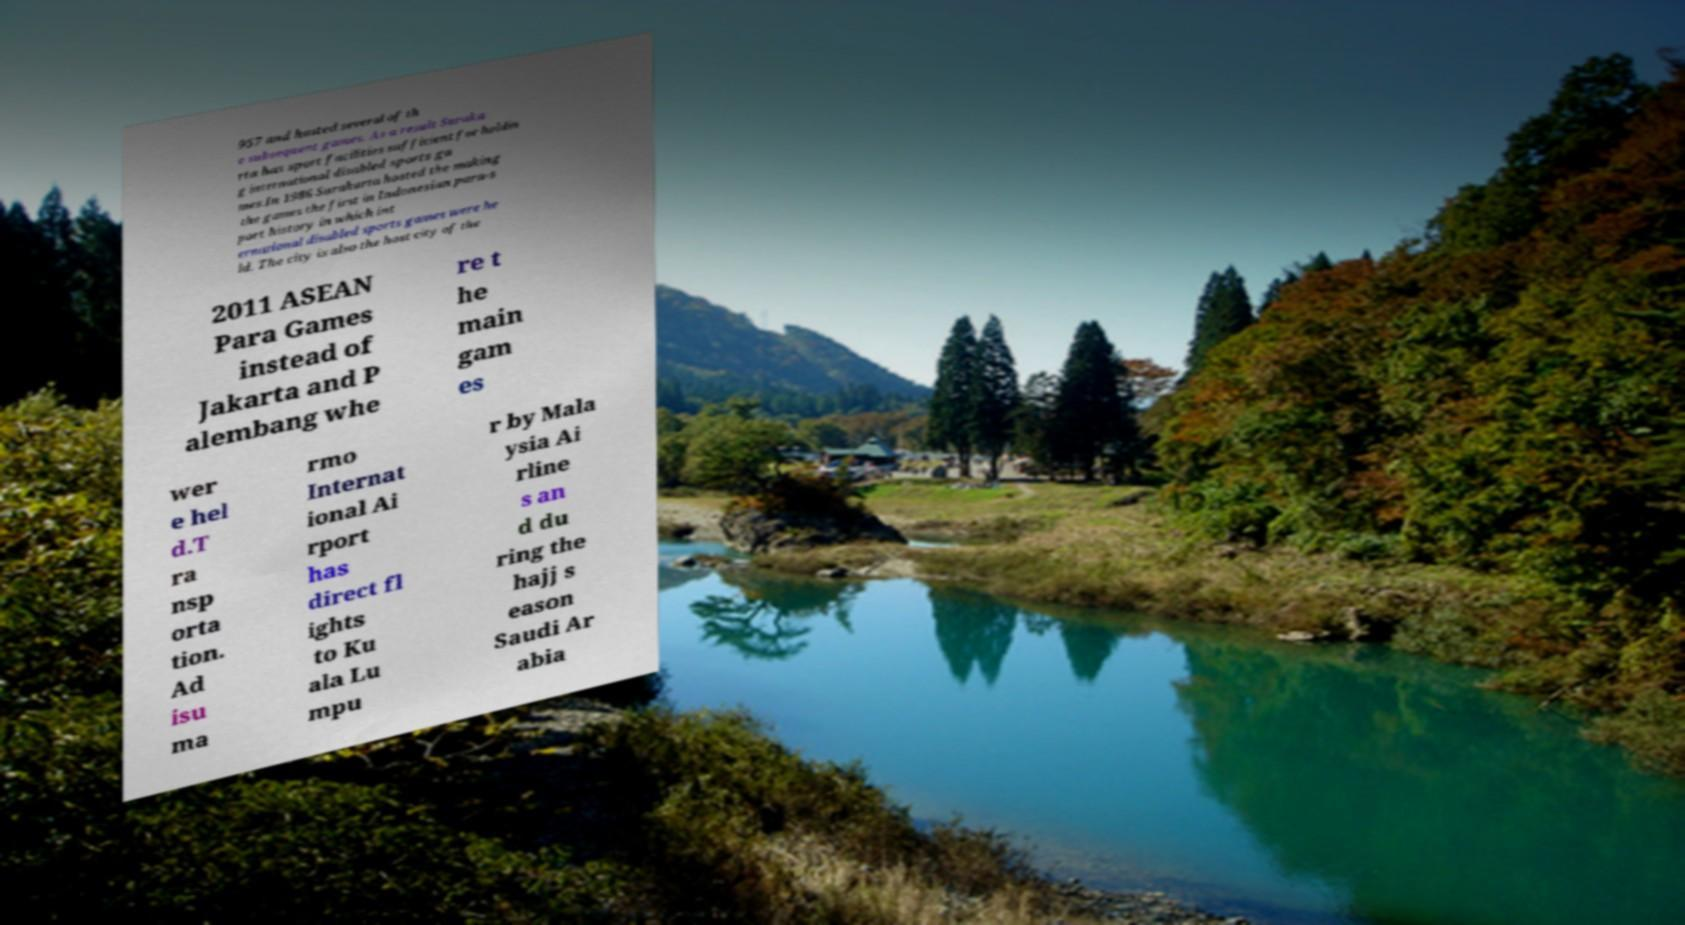Can you read and provide the text displayed in the image?This photo seems to have some interesting text. Can you extract and type it out for me? 957 and hosted several of th e subsequent games. As a result Suraka rta has sport facilities sufficient for holdin g international disabled sports ga mes.In 1986 Surakarta hosted the making the games the first in Indonesian para-s port history in which int ernational disabled sports games were he ld. The city is also the host city of the 2011 ASEAN Para Games instead of Jakarta and P alembang whe re t he main gam es wer e hel d.T ra nsp orta tion. Ad isu ma rmo Internat ional Ai rport has direct fl ights to Ku ala Lu mpu r by Mala ysia Ai rline s an d du ring the hajj s eason Saudi Ar abia 